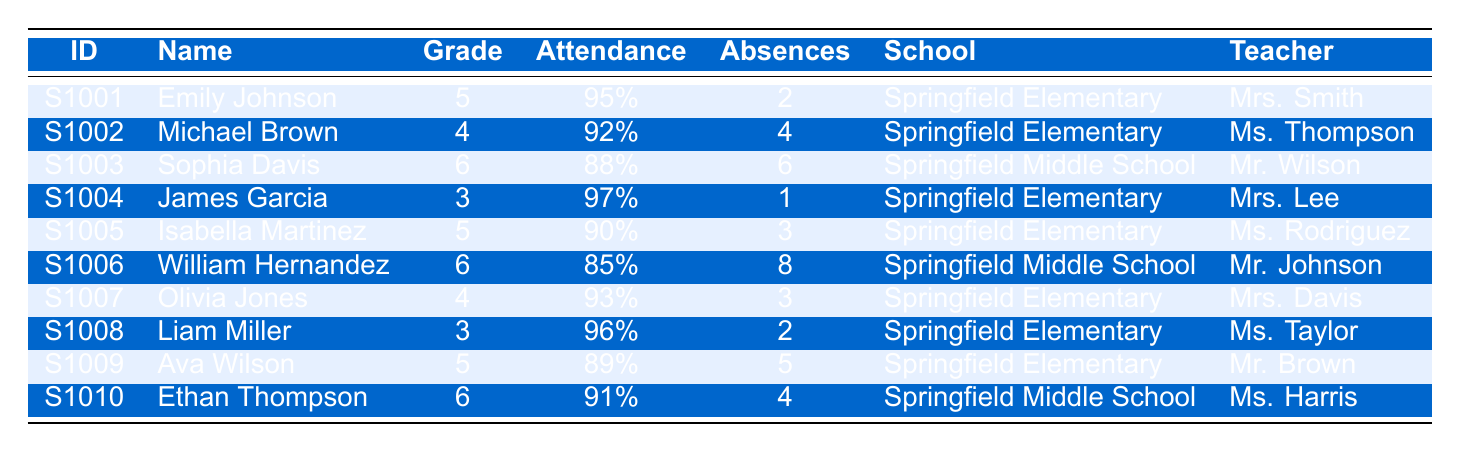What is the attendance rate of Emily Johnson? Emily Johnson's attendance rate is directly provided in the table under the "Attendance" column. It shows that her rate is 95%.
Answer: 95% Who is the homeroom teacher for Liam Miller? The table lists the homeroom teacher for each student in the "Teacher" column. For Liam Miller, his teacher is Ms. Taylor.
Answer: Ms. Taylor How many absent days did Michael Brown have? The table provides the number of absent days in the "Absences" column. Michael Brown had 4 absent days.
Answer: 4 What is the average attendance rate for students in grade 6? To find the average attendance rate for grade 6, we add the attendance rates of Sophia Davis (88%), William Hernandez (85%), and Ethan Thompson (91%). The sum is 88 + 85 + 91 = 264. There are 3 students, so average = 264/3 = 88%.
Answer: 88% Which student had the highest attendance rate? We need to compare all attendance rates in the "Attendance" column. The highest rate is 97%, achieved by James Garcia.
Answer: James Garcia Is it true that Olivia Jones has more absent days than Isabella Martinez? Olivia Jones has 3 absent days while Isabella Martinez has 3 absent days. Since both are equal, the statement is false.
Answer: No How many students from Springfield Elementary have an attendance rate of 90% or higher? We examine the "Attendance" column for Springfield Elementary. The students with rates of 90% or higher are Emily Johnson (95%), James Garcia (97%), Liam Miller (96%), and Olivia Jones (93%). This totals 4 students.
Answer: 4 What is the total number of absent days for all students at Springfield Middle School? We look at the "Absences" column for Springfield Middle School students—Sophia Davis (6), William Hernandez (8), and Ethan Thompson (4). The total is 6 + 8 + 4 = 18 absent days.
Answer: 18 Which student had the most absent days and how many did they have? By checking the "Absences" column, William Hernandez has the highest number of absent days at 8.
Answer: William Hernandez, 8 What percentage of students in Springfield Elementary have an attendance rate below 90%? The total number of students in Springfield Elementary is 6. Those with attendance below 90% are Isabella Martinez (90%), and Ava Wilson (89%). Therefore, only Ava Wilson is below 90%, so 1 out of 6 students gives a percentage of (1/6) * 100 ≈ 16.67%.
Answer: Approximately 16.67% 